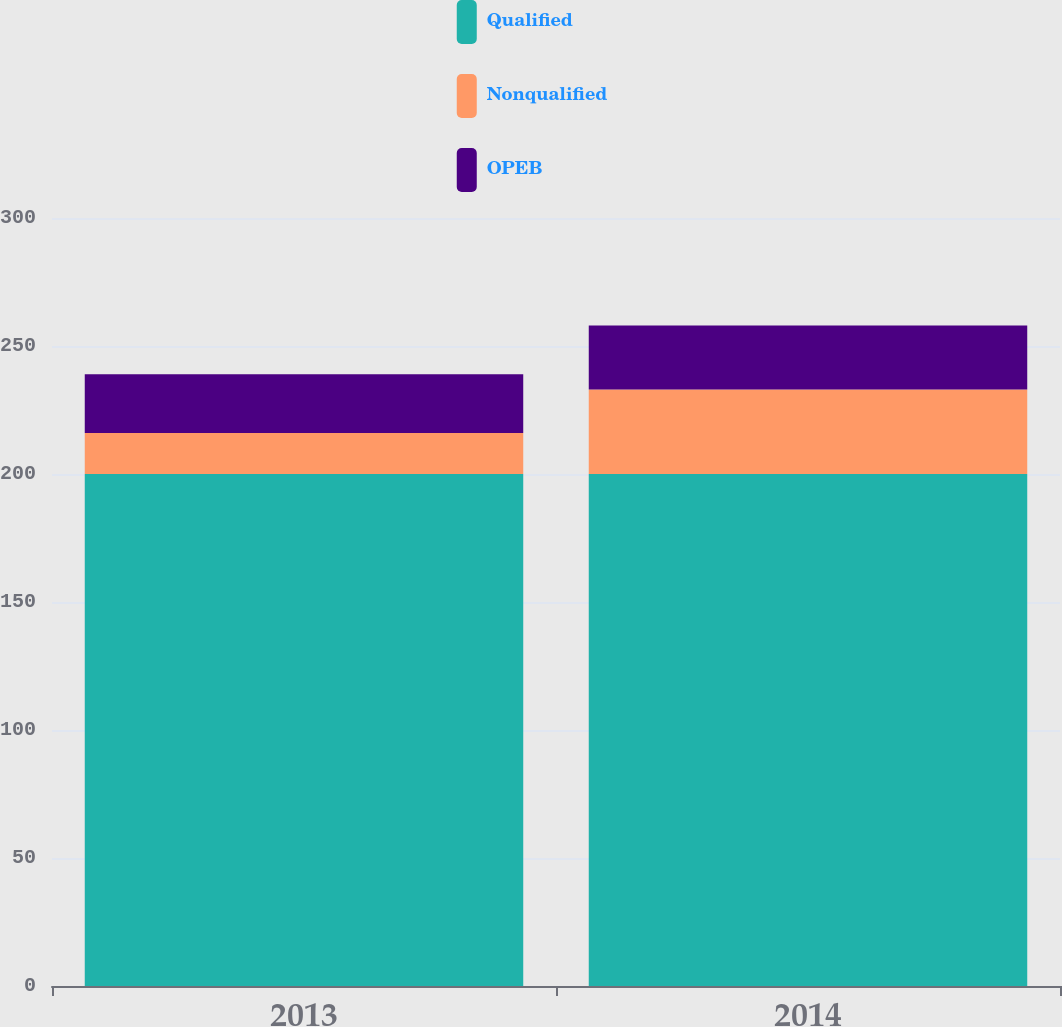<chart> <loc_0><loc_0><loc_500><loc_500><stacked_bar_chart><ecel><fcel>2013<fcel>2014<nl><fcel>Qualified<fcel>200<fcel>200<nl><fcel>Nonqualified<fcel>16<fcel>33<nl><fcel>OPEB<fcel>23<fcel>25<nl></chart> 